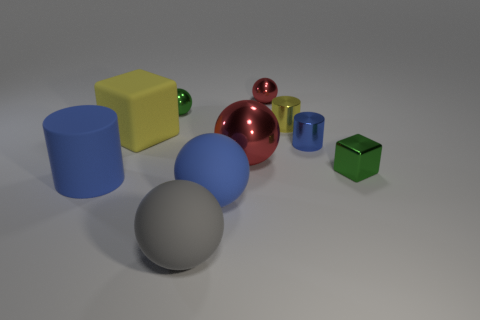Subtract all blue balls. How many balls are left? 4 Subtract all cyan balls. Subtract all blue blocks. How many balls are left? 5 Subtract all cylinders. How many objects are left? 7 Add 7 blue objects. How many blue objects are left? 10 Add 2 small yellow matte balls. How many small yellow matte balls exist? 2 Subtract 0 brown blocks. How many objects are left? 10 Subtract all tiny cylinders. Subtract all small yellow cylinders. How many objects are left? 7 